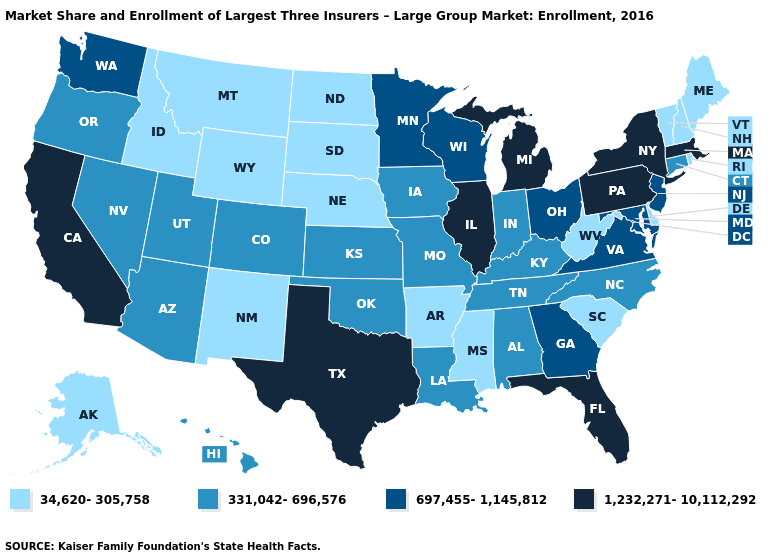Does Texas have the highest value in the South?
Concise answer only. Yes. Does the map have missing data?
Keep it brief. No. Does Kentucky have the same value as Rhode Island?
Write a very short answer. No. Among the states that border Virginia , which have the highest value?
Concise answer only. Maryland. Name the states that have a value in the range 331,042-696,576?
Keep it brief. Alabama, Arizona, Colorado, Connecticut, Hawaii, Indiana, Iowa, Kansas, Kentucky, Louisiana, Missouri, Nevada, North Carolina, Oklahoma, Oregon, Tennessee, Utah. What is the value of Texas?
Be succinct. 1,232,271-10,112,292. Name the states that have a value in the range 1,232,271-10,112,292?
Keep it brief. California, Florida, Illinois, Massachusetts, Michigan, New York, Pennsylvania, Texas. Name the states that have a value in the range 697,455-1,145,812?
Concise answer only. Georgia, Maryland, Minnesota, New Jersey, Ohio, Virginia, Washington, Wisconsin. Name the states that have a value in the range 697,455-1,145,812?
Short answer required. Georgia, Maryland, Minnesota, New Jersey, Ohio, Virginia, Washington, Wisconsin. Among the states that border West Virginia , does Kentucky have the lowest value?
Answer briefly. Yes. Among the states that border Idaho , which have the lowest value?
Keep it brief. Montana, Wyoming. Does Florida have the same value as Pennsylvania?
Concise answer only. Yes. Name the states that have a value in the range 331,042-696,576?
Concise answer only. Alabama, Arizona, Colorado, Connecticut, Hawaii, Indiana, Iowa, Kansas, Kentucky, Louisiana, Missouri, Nevada, North Carolina, Oklahoma, Oregon, Tennessee, Utah. Which states have the lowest value in the USA?
Give a very brief answer. Alaska, Arkansas, Delaware, Idaho, Maine, Mississippi, Montana, Nebraska, New Hampshire, New Mexico, North Dakota, Rhode Island, South Carolina, South Dakota, Vermont, West Virginia, Wyoming. 